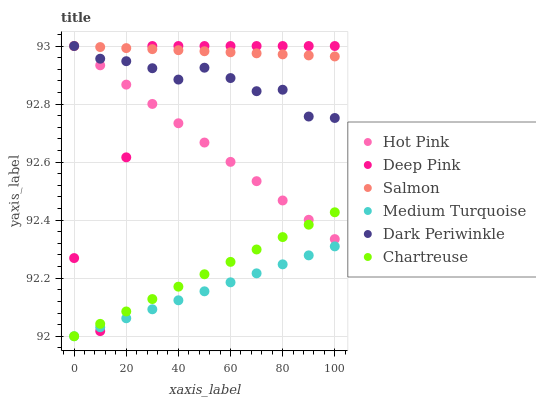Does Medium Turquoise have the minimum area under the curve?
Answer yes or no. Yes. Does Salmon have the maximum area under the curve?
Answer yes or no. Yes. Does Hot Pink have the minimum area under the curve?
Answer yes or no. No. Does Hot Pink have the maximum area under the curve?
Answer yes or no. No. Is Chartreuse the smoothest?
Answer yes or no. Yes. Is Deep Pink the roughest?
Answer yes or no. Yes. Is Hot Pink the smoothest?
Answer yes or no. No. Is Hot Pink the roughest?
Answer yes or no. No. Does Chartreuse have the lowest value?
Answer yes or no. Yes. Does Hot Pink have the lowest value?
Answer yes or no. No. Does Dark Periwinkle have the highest value?
Answer yes or no. Yes. Does Chartreuse have the highest value?
Answer yes or no. No. Is Chartreuse less than Salmon?
Answer yes or no. Yes. Is Salmon greater than Medium Turquoise?
Answer yes or no. Yes. Does Deep Pink intersect Medium Turquoise?
Answer yes or no. Yes. Is Deep Pink less than Medium Turquoise?
Answer yes or no. No. Is Deep Pink greater than Medium Turquoise?
Answer yes or no. No. Does Chartreuse intersect Salmon?
Answer yes or no. No. 